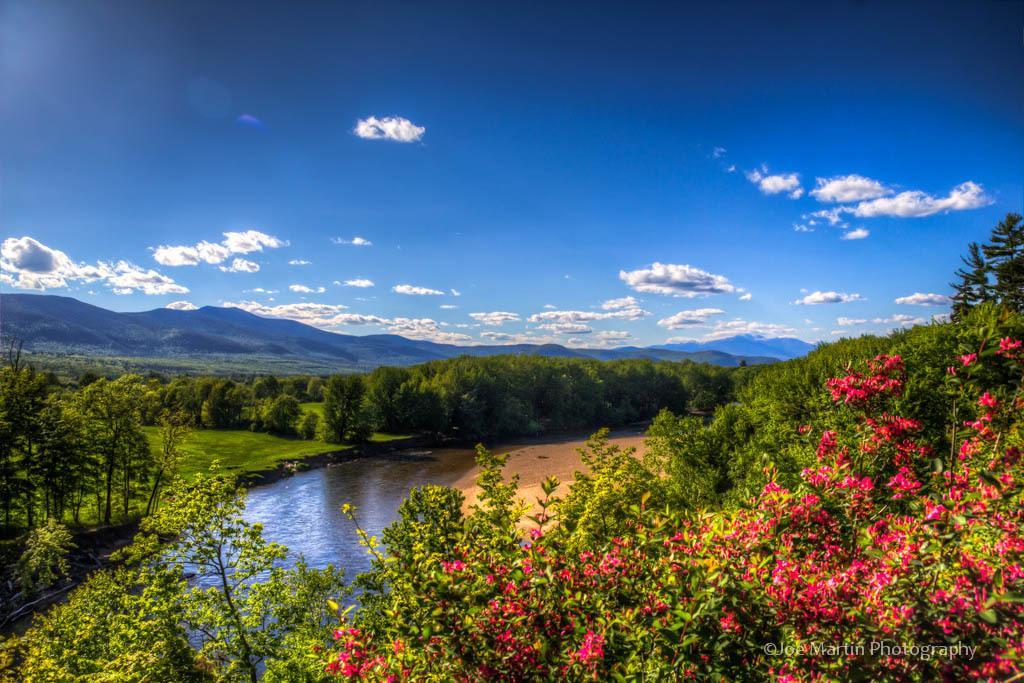Can you describe this image briefly? In the foreground of this image, there are flowers to the plants. In the background, there is a river, trees, mountains, sky and the cloud. 